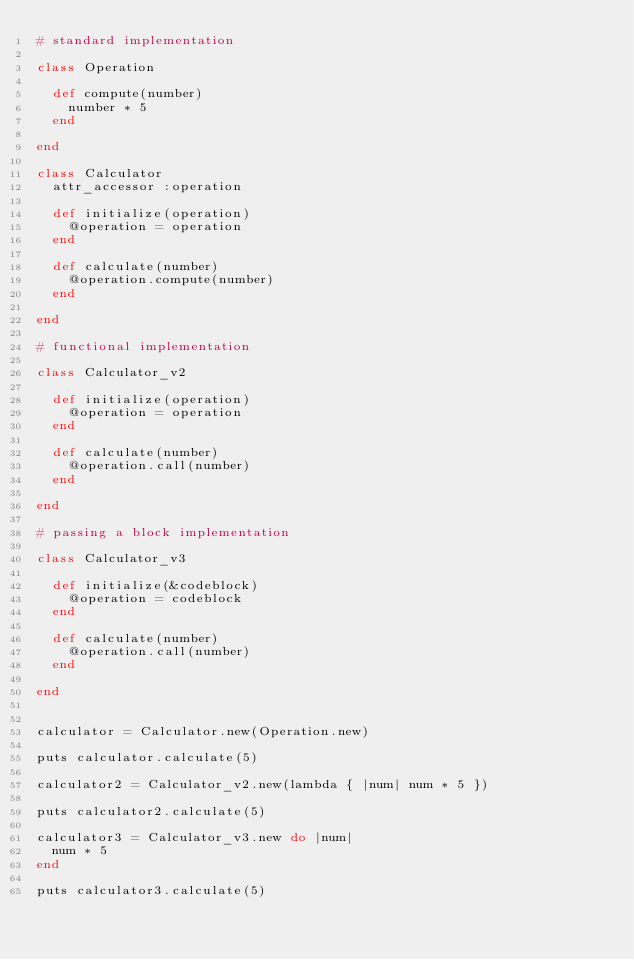<code> <loc_0><loc_0><loc_500><loc_500><_Ruby_># standard implementation

class Operation

  def compute(number)
    number * 5
  end

end

class Calculator
  attr_accessor :operation

  def initialize(operation)
    @operation = operation
  end

  def calculate(number)
    @operation.compute(number)
  end

end

# functional implementation

class Calculator_v2

  def initialize(operation)
    @operation = operation
  end

  def calculate(number)
    @operation.call(number)
  end

end

# passing a block implementation

class Calculator_v3

  def initialize(&codeblock)
    @operation = codeblock
  end

  def calculate(number)
    @operation.call(number)
  end

end


calculator = Calculator.new(Operation.new)

puts calculator.calculate(5)

calculator2 = Calculator_v2.new(lambda { |num| num * 5 })

puts calculator2.calculate(5)

calculator3 = Calculator_v3.new do |num|
  num * 5
end

puts calculator3.calculate(5)
</code> 